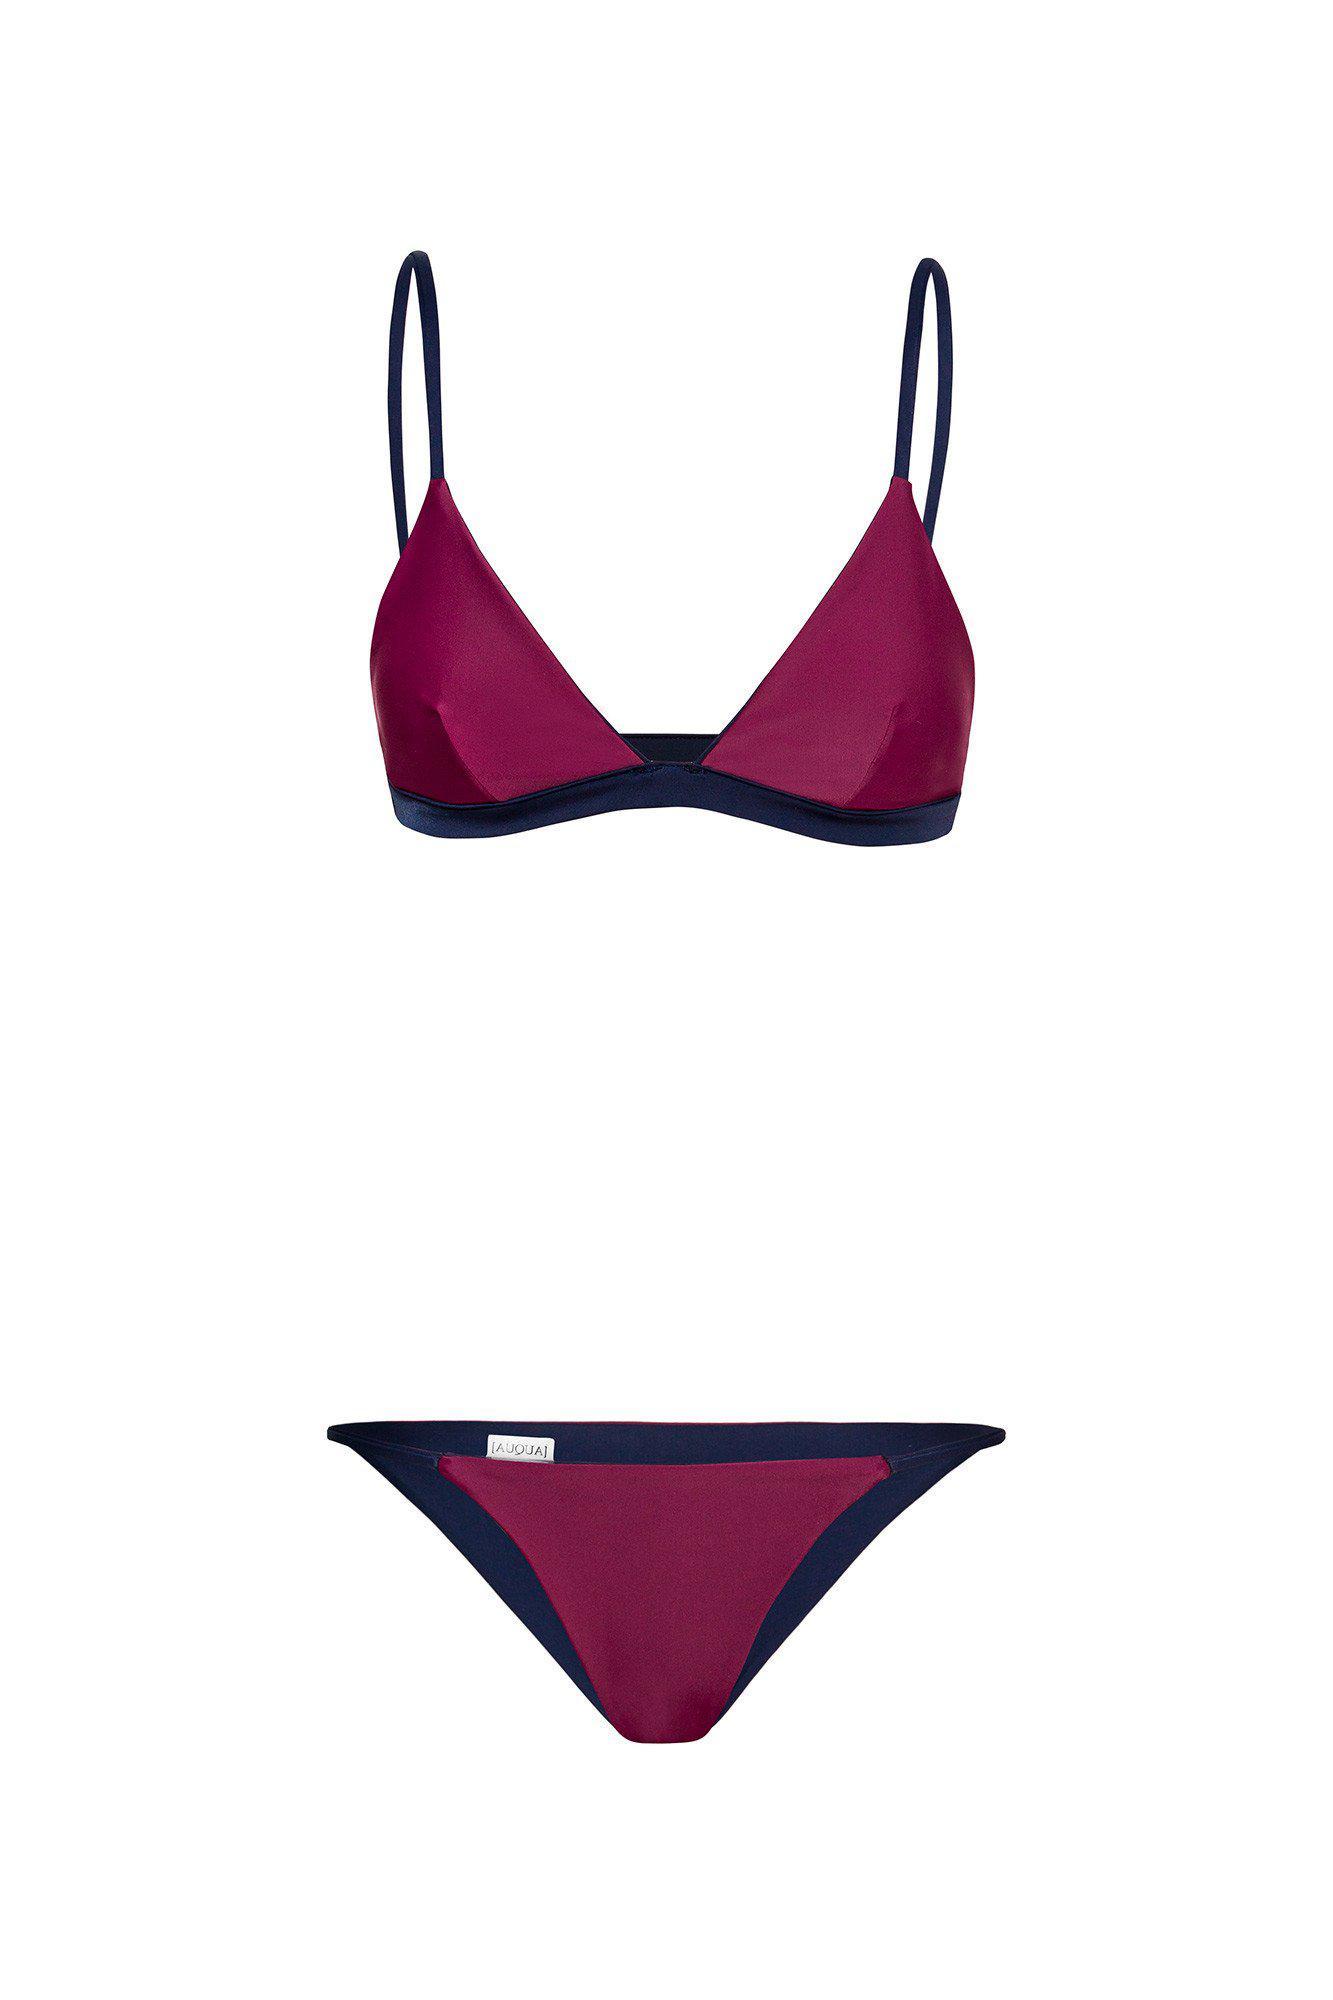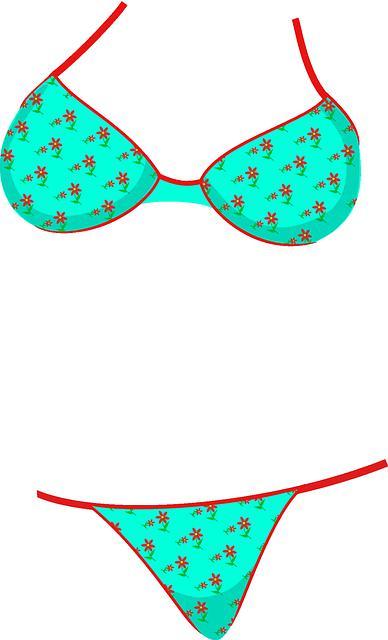The first image is the image on the left, the second image is the image on the right. Analyze the images presented: Is the assertion "All bikini tops are over-the-shoulder style, rather than tied around the neck." valid? Answer yes or no. No. 